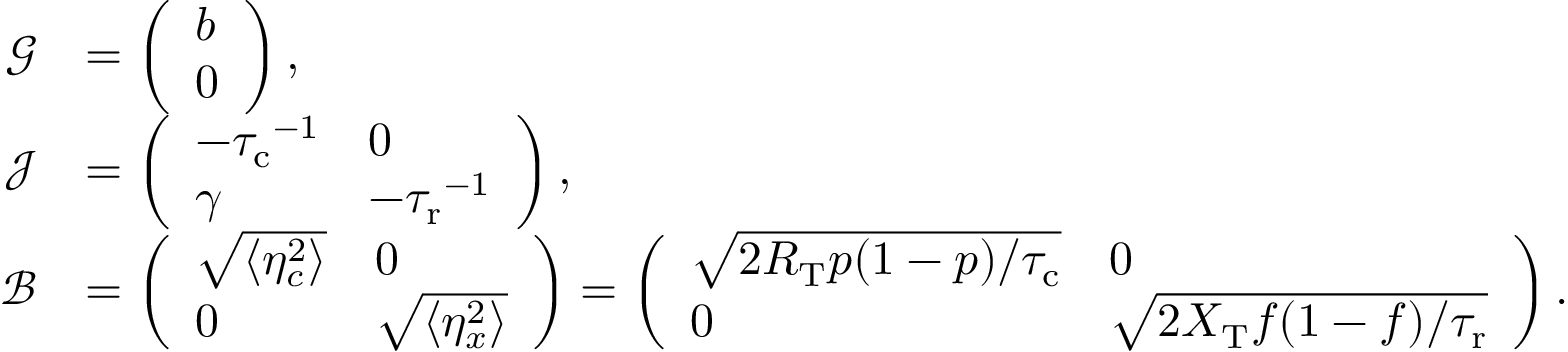<formula> <loc_0><loc_0><loc_500><loc_500>\begin{array} { r l } { \mathcal { G } } & { = \left ( \begin{array} { l } { b } \\ { 0 } \end{array} \right ) , } \\ { \mathcal { J } } & { = \left ( \begin{array} { l l } { - { \tau _ { c } } ^ { - 1 } } & { 0 } \\ { \gamma } & { - { \tau _ { r } } ^ { - 1 } } \end{array} \right ) , } \\ { \mathcal { B } } & { = \left ( \begin{array} { l l } { \sqrt { \langle \eta _ { c } ^ { 2 } \rangle } } & { 0 } \\ { 0 } & { \sqrt { \langle \eta _ { x } ^ { 2 } \rangle } } \end{array} \right ) = \left ( \begin{array} { l l } { \sqrt { 2 R _ { T } p ( 1 - p ) / { \tau _ { c } } } } & { 0 } \\ { 0 } & { \sqrt { 2 X _ { T } f ( 1 - f ) / { \tau _ { r } } } } \end{array} \right ) . } \end{array}</formula> 